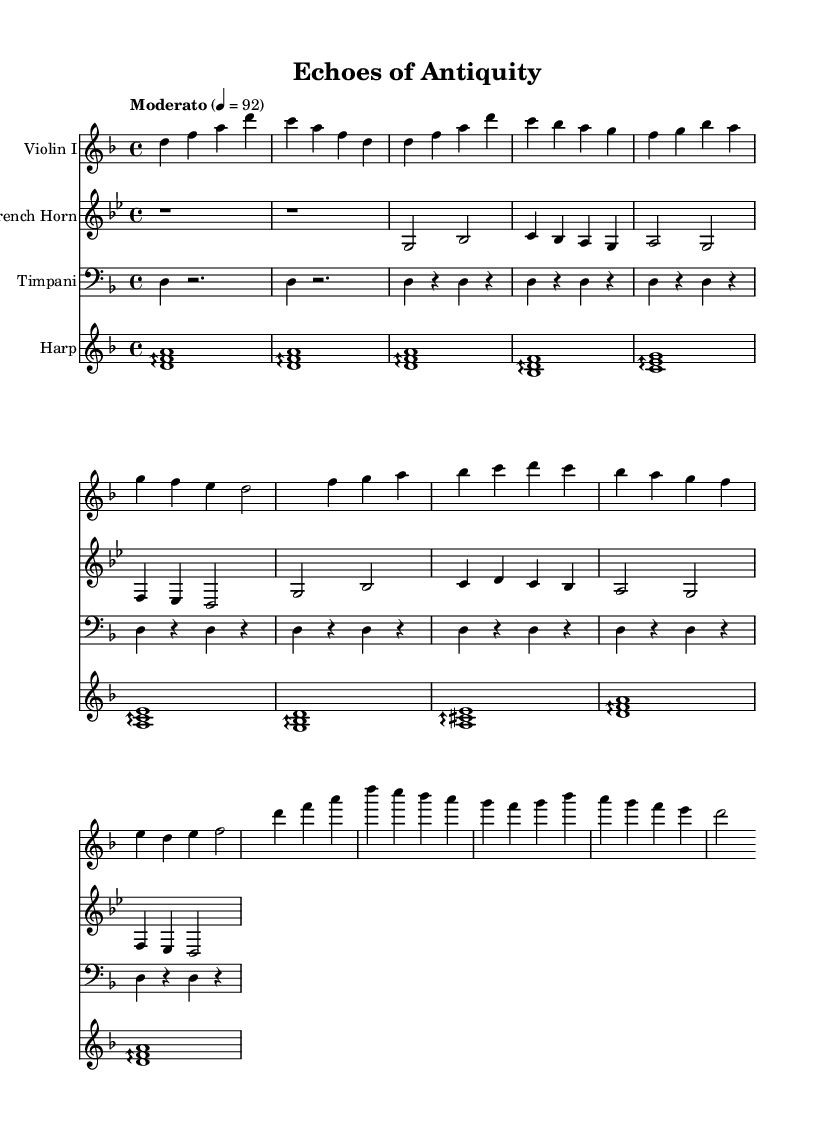What is the key signature of this music? The key signature indicated at the beginning shows two flats (B♭ and E♭), which corresponds to D minor.
Answer: D minor What is the time signature of this music? The time signature shown at the beginning is 4/4, meaning there are four beats in each measure and the quarter note receives one beat.
Answer: 4/4 What is the tempo marking given for this piece? The tempo marking "Moderato" suggests a moderate speed, often interpreted as a medium pace for the piece.
Answer: Moderato How many distinct musical themes are presented in the score? The score contains two distinct musical themes labeled as Theme A and Theme B, which can be identified by their unique melodic lines in the notation.
Answer: Two In which section does the climax of the music occur? The climactic section is indicated by a repeated pattern of the initial melody and is represented in the notation as "Climax," suggesting it's a high point in the emotional narrative of the piece.
Answer: Climax What instruments are featured in this score? The score includes a violin, french horn, timpani, and harp, which are specified at the beginning of each staff, showcasing a diverse orchestral palette.
Answer: Violin, French Horn, Timpani, Harp What type of musical technique is predominantly used in the harp part? The harp part displays arpeggios, which are executed by playing the notes of a chord in rapid succession, creating a fluid and shimmering sound texture.
Answer: Arpeggios 